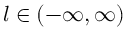<formula> <loc_0><loc_0><loc_500><loc_500>l \in ( - \infty , \infty )</formula> 